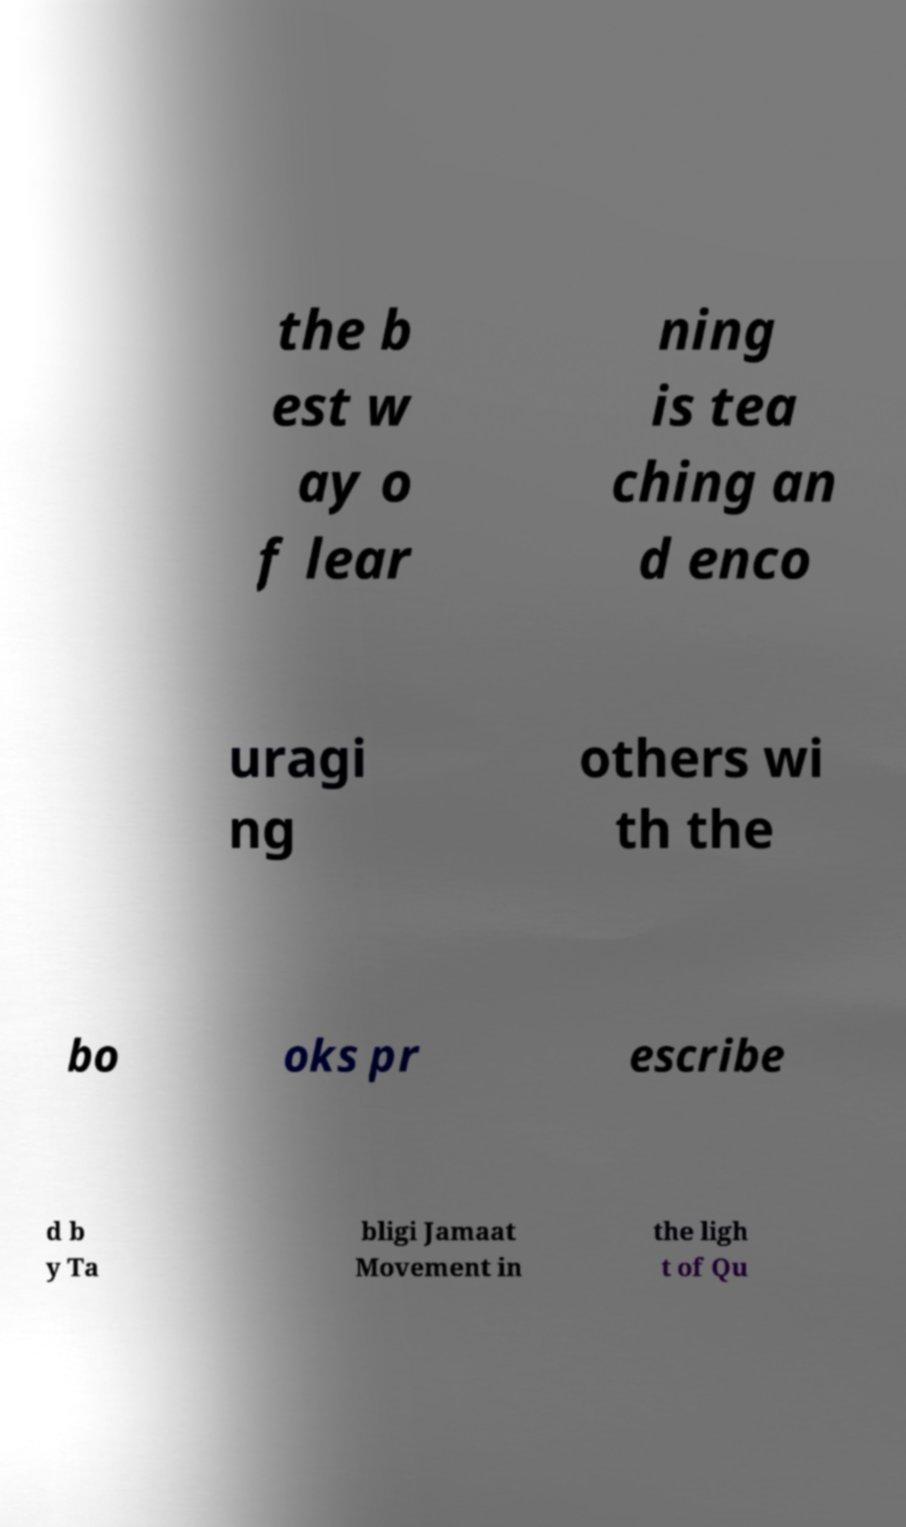Could you extract and type out the text from this image? the b est w ay o f lear ning is tea ching an d enco uragi ng others wi th the bo oks pr escribe d b y Ta bligi Jamaat Movement in the ligh t of Qu 